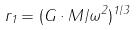<formula> <loc_0><loc_0><loc_500><loc_500>r _ { 1 } = ( G \cdot M / \omega ^ { 2 } ) ^ { 1 / 3 }</formula> 